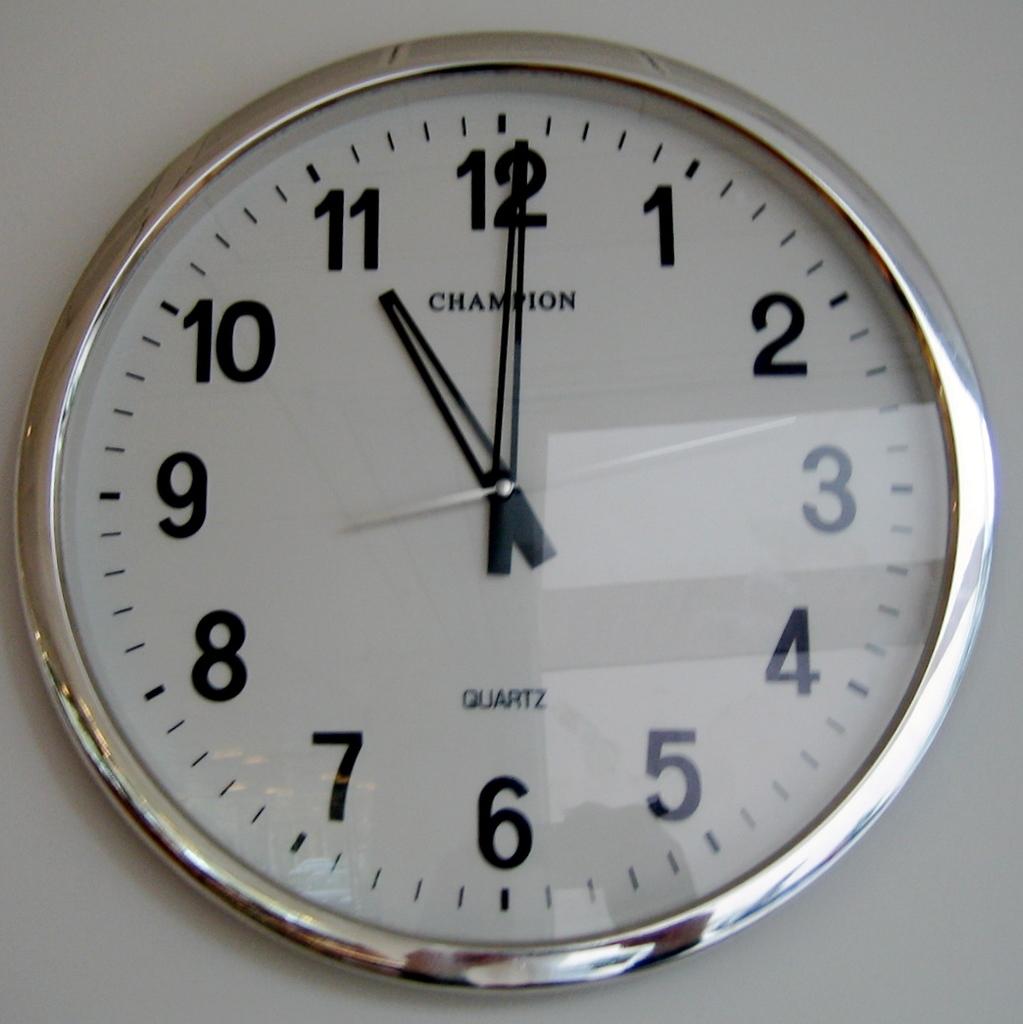Is this a champion watch?
Give a very brief answer. Yes. What is the time?
Keep it short and to the point. 11:00. 